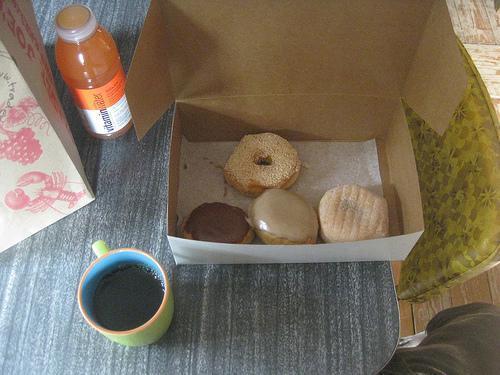How many people are in the photo?
Give a very brief answer. 0. How many doughnuts are there?
Give a very brief answer. 4. 